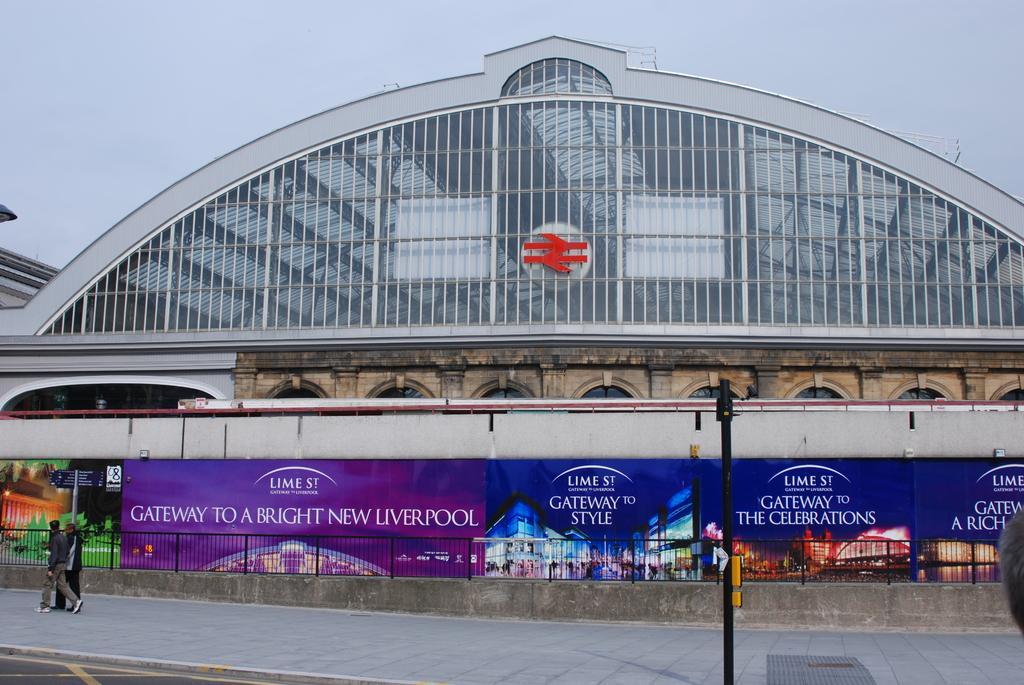Can you describe this image briefly? In the center of the image we can see a building, bridge, boards, grille, wall, logo, pole. On the left side of the image we can see two persons are walking. At the bottom of the image we can see the road. At the top of the image we can see the sky. 